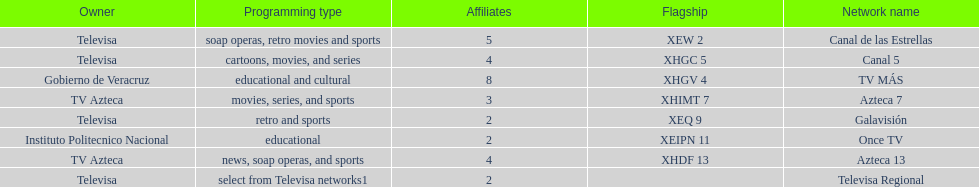Who has the most number of affiliates? TV MÁS. 